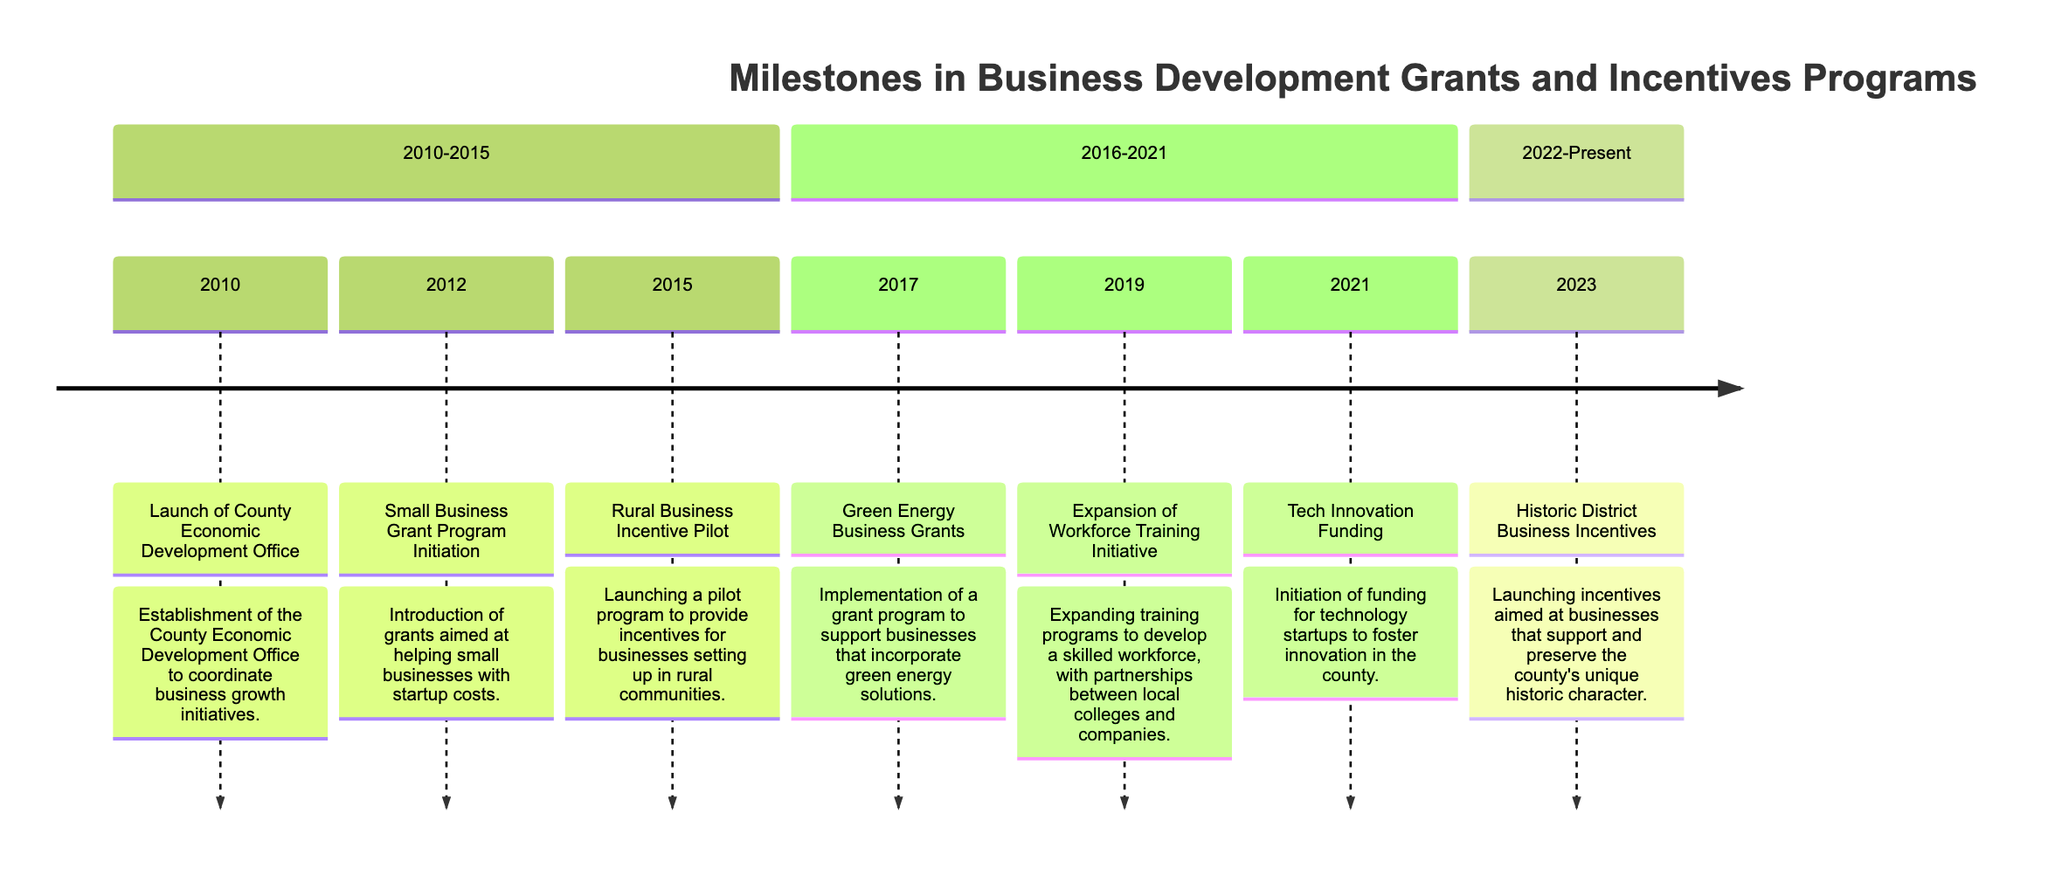What's the first event listed in the timeline? The timeline begins with the event that took place in 2010, which is the "Launch of County Economic Development Office." This is the first milestone shown in the diagram.
Answer: Launch of County Economic Development Office What year did the Small Business Grant Program Initiation occur? The Small Business Grant Program was initiated in the year 2012, as indicated in the timeline.
Answer: 2012 How many business incentive programs were introduced between 2010 and 2015? There are three business incentive programs introduced during this period: "Launch of County Economic Development Office" in 2010, "Small Business Grant Program Initiation" in 2012, and "Rural Business Incentive Pilot" in 2015. Counting these gives us a total of three programs.
Answer: 3 What is the last event listed in the timeline? The last event in the timeline is "Historic District Business Incentives," which occurred in 2023. This is the most recent milestone displayed in the diagram.
Answer: Historic District Business Incentives Which milestone focused on green energy solutions? The milestone that focused on green energy solutions is "Green Energy Business Grants," which occurred in 2017. This is explicitly stated in the description of the event.
Answer: Green Energy Business Grants How many years are between the initiation of the Small Business Grant Program and the launch of the Tech Innovation Funding? The Small Business Grant Program was initiated in 2012, and the Tech Innovation Funding was initiated in 2021. The difference in years between these two events is 9 years.
Answer: 9 What series of events occurred in the timeline from 2016 to 2021? In the timeline from 2016 to 2021, there are three events listed: "Green Energy Business Grants" in 2017, "Expansion of Workforce Training Initiative" in 2019, and "Tech Innovation Funding" in 2021. This sequence shows the ongoing development of business incentives during this period.
Answer: Green Energy Business Grants, Expansion of Workforce Training Initiative, Tech Innovation Funding What recent initiative supports preserving the county’s historic character? The recent initiative that aims at preserving the county’s unique historic character is the "Historic District Business Incentives," which was introduced in 2023. This is explicitly aimed at businesses that support historical preservation.
Answer: Historic District Business Incentives 